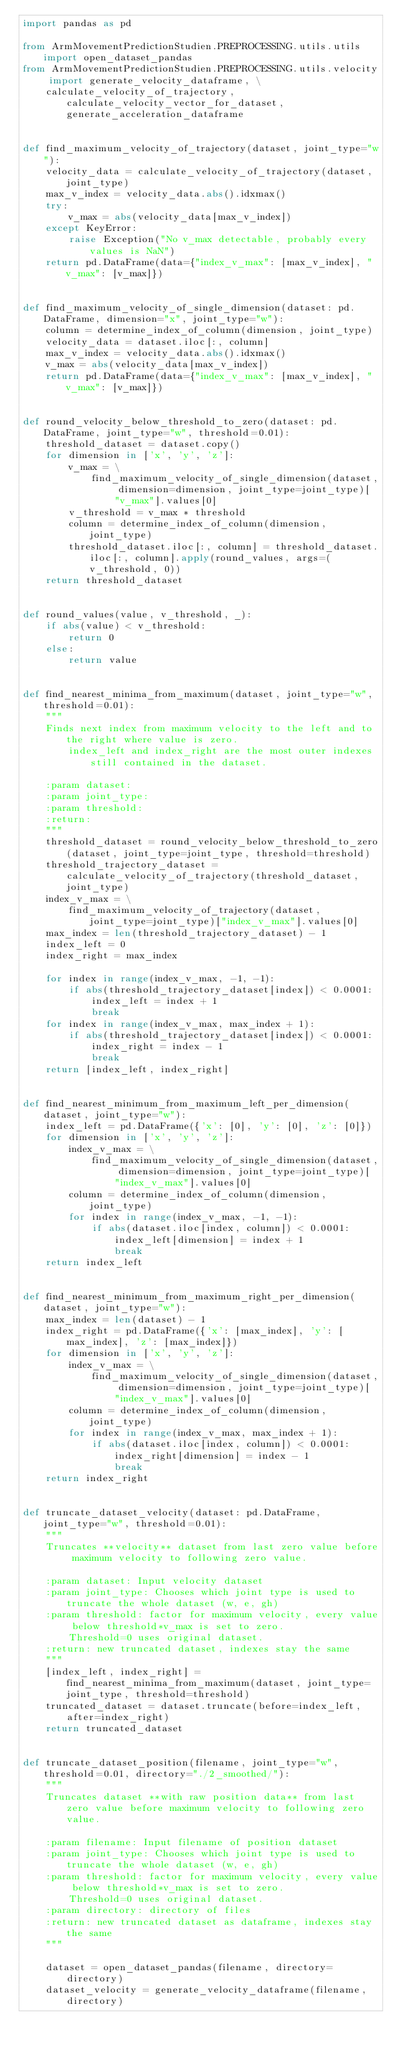Convert code to text. <code><loc_0><loc_0><loc_500><loc_500><_Python_>import pandas as pd

from ArmMovementPredictionStudien.PREPROCESSING.utils.utils import open_dataset_pandas
from ArmMovementPredictionStudien.PREPROCESSING.utils.velocity import generate_velocity_dataframe, \
    calculate_velocity_of_trajectory, calculate_velocity_vector_for_dataset, generate_acceleration_dataframe


def find_maximum_velocity_of_trajectory(dataset, joint_type="w"):
    velocity_data = calculate_velocity_of_trajectory(dataset, joint_type)
    max_v_index = velocity_data.abs().idxmax()
    try:
        v_max = abs(velocity_data[max_v_index])
    except KeyError:
        raise Exception("No v_max detectable, probably every values is NaN")
    return pd.DataFrame(data={"index_v_max": [max_v_index], "v_max": [v_max]})


def find_maximum_velocity_of_single_dimension(dataset: pd.DataFrame, dimension="x", joint_type="w"):
    column = determine_index_of_column(dimension, joint_type)
    velocity_data = dataset.iloc[:, column]
    max_v_index = velocity_data.abs().idxmax()
    v_max = abs(velocity_data[max_v_index])
    return pd.DataFrame(data={"index_v_max": [max_v_index], "v_max": [v_max]})


def round_velocity_below_threshold_to_zero(dataset: pd.DataFrame, joint_type="w", threshold=0.01):
    threshold_dataset = dataset.copy()
    for dimension in ['x', 'y', 'z']:
        v_max = \
            find_maximum_velocity_of_single_dimension(dataset, dimension=dimension, joint_type=joint_type)[
                "v_max"].values[0]
        v_threshold = v_max * threshold
        column = determine_index_of_column(dimension, joint_type)
        threshold_dataset.iloc[:, column] = threshold_dataset.iloc[:, column].apply(round_values, args=(v_threshold, 0))
    return threshold_dataset


def round_values(value, v_threshold, _):
    if abs(value) < v_threshold:
        return 0
    else:
        return value


def find_nearest_minima_from_maximum(dataset, joint_type="w", threshold=0.01):
    """
    Finds next index from maximum velocity to the left and to the right where value is zero.
        index_left and index_right are the most outer indexes still contained in the dataset.

    :param dataset:
    :param joint_type:
    :param threshold:
    :return:
    """
    threshold_dataset = round_velocity_below_threshold_to_zero(dataset, joint_type=joint_type, threshold=threshold)
    threshold_trajectory_dataset = calculate_velocity_of_trajectory(threshold_dataset, joint_type)
    index_v_max = \
        find_maximum_velocity_of_trajectory(dataset, joint_type=joint_type)["index_v_max"].values[0]
    max_index = len(threshold_trajectory_dataset) - 1
    index_left = 0
    index_right = max_index

    for index in range(index_v_max, -1, -1):
        if abs(threshold_trajectory_dataset[index]) < 0.0001:
            index_left = index + 1
            break
    for index in range(index_v_max, max_index + 1):
        if abs(threshold_trajectory_dataset[index]) < 0.0001:
            index_right = index - 1
            break
    return [index_left, index_right]


def find_nearest_minimum_from_maximum_left_per_dimension(dataset, joint_type="w"):
    index_left = pd.DataFrame({'x': [0], 'y': [0], 'z': [0]})
    for dimension in ['x', 'y', 'z']:
        index_v_max = \
            find_maximum_velocity_of_single_dimension(dataset, dimension=dimension, joint_type=joint_type)[
                "index_v_max"].values[0]
        column = determine_index_of_column(dimension, joint_type)
        for index in range(index_v_max, -1, -1):
            if abs(dataset.iloc[index, column]) < 0.0001:
                index_left[dimension] = index + 1
                break
    return index_left


def find_nearest_minimum_from_maximum_right_per_dimension(dataset, joint_type="w"):
    max_index = len(dataset) - 1
    index_right = pd.DataFrame({'x': [max_index], 'y': [max_index], 'z': [max_index]})
    for dimension in ['x', 'y', 'z']:
        index_v_max = \
            find_maximum_velocity_of_single_dimension(dataset, dimension=dimension, joint_type=joint_type)[
                "index_v_max"].values[0]
        column = determine_index_of_column(dimension, joint_type)
        for index in range(index_v_max, max_index + 1):
            if abs(dataset.iloc[index, column]) < 0.0001:
                index_right[dimension] = index - 1
                break
    return index_right


def truncate_dataset_velocity(dataset: pd.DataFrame, joint_type="w", threshold=0.01):
    """
    Truncates **velocity** dataset from last zero value before maximum velocity to following zero value.

    :param dataset: Input velocity dataset
    :param joint_type: Chooses which joint type is used to truncate the whole dataset (w, e, gh)
    :param threshold: factor for maximum velocity, every value below threshold*v_max is set to zero.
        Threshold=0 uses original dataset.
    :return: new truncated dataset, indexes stay the same
    """
    [index_left, index_right] = find_nearest_minima_from_maximum(dataset, joint_type=joint_type, threshold=threshold)
    truncated_dataset = dataset.truncate(before=index_left, after=index_right)
    return truncated_dataset


def truncate_dataset_position(filename, joint_type="w", threshold=0.01, directory="./2_smoothed/"):
    """
    Truncates dataset **with raw position data** from last zero value before maximum velocity to following zero value.

    :param filename: Input filename of position dataset
    :param joint_type: Chooses which joint type is used to truncate the whole dataset (w, e, gh)
    :param threshold: factor for maximum velocity, every value below threshold*v_max is set to zero.
        Threshold=0 uses original dataset.
    :param directory: directory of files
    :return: new truncated dataset as dataframe, indexes stay the same
    """

    dataset = open_dataset_pandas(filename, directory=directory)
    dataset_velocity = generate_velocity_dataframe(filename, directory)</code> 